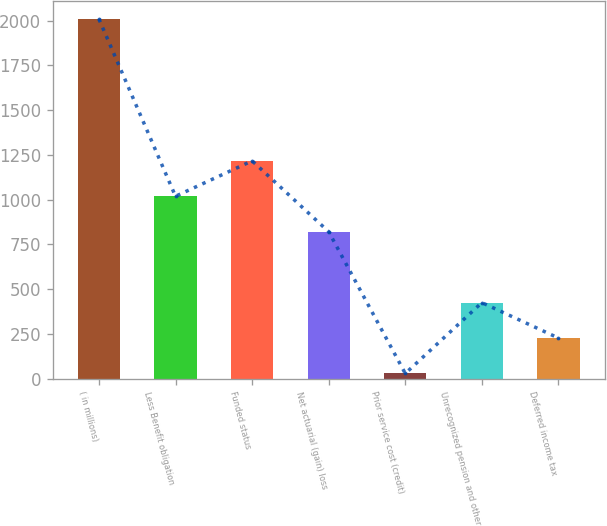<chart> <loc_0><loc_0><loc_500><loc_500><bar_chart><fcel>( in millions)<fcel>Less Benefit obligation<fcel>Funded status<fcel>Net actuarial (gain) loss<fcel>Prior service cost (credit)<fcel>Unrecognized pension and other<fcel>Deferred income tax<nl><fcel>2008<fcel>1018.5<fcel>1216.4<fcel>820.6<fcel>29<fcel>424.8<fcel>226.9<nl></chart> 